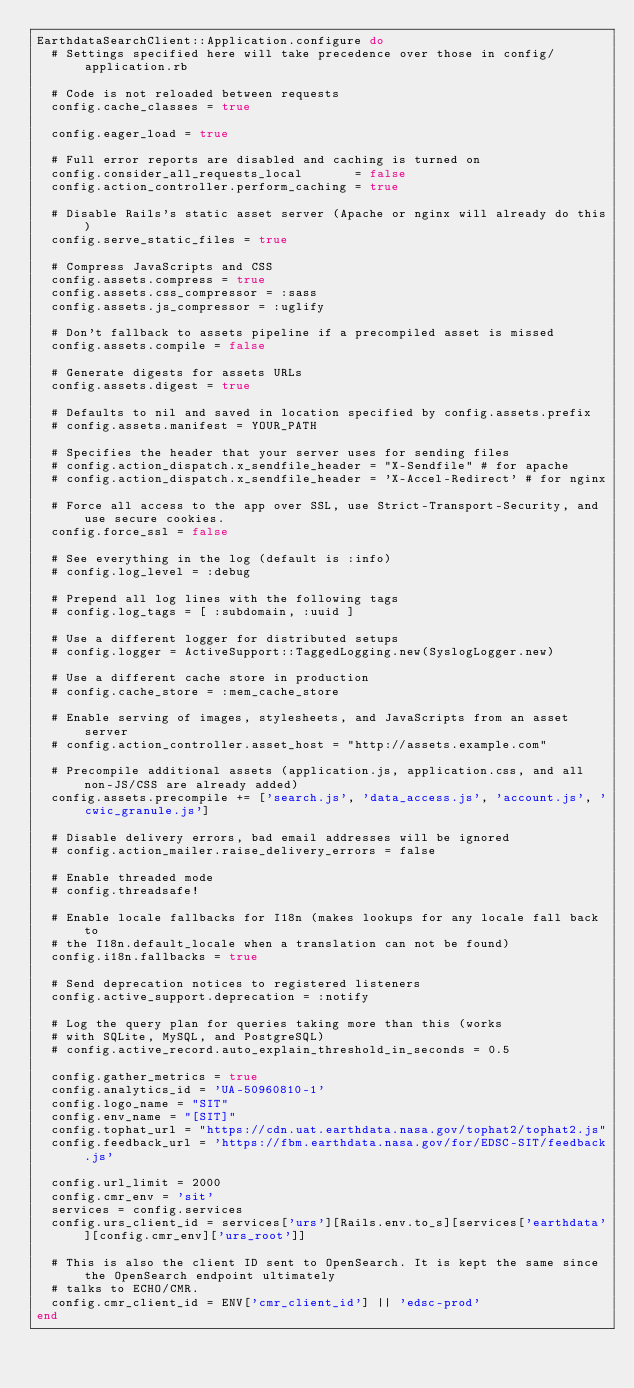Convert code to text. <code><loc_0><loc_0><loc_500><loc_500><_Ruby_>EarthdataSearchClient::Application.configure do
  # Settings specified here will take precedence over those in config/application.rb

  # Code is not reloaded between requests
  config.cache_classes = true

  config.eager_load = true

  # Full error reports are disabled and caching is turned on
  config.consider_all_requests_local       = false
  config.action_controller.perform_caching = true

  # Disable Rails's static asset server (Apache or nginx will already do this)
  config.serve_static_files = true

  # Compress JavaScripts and CSS
  config.assets.compress = true
  config.assets.css_compressor = :sass
  config.assets.js_compressor = :uglify

  # Don't fallback to assets pipeline if a precompiled asset is missed
  config.assets.compile = false

  # Generate digests for assets URLs
  config.assets.digest = true

  # Defaults to nil and saved in location specified by config.assets.prefix
  # config.assets.manifest = YOUR_PATH

  # Specifies the header that your server uses for sending files
  # config.action_dispatch.x_sendfile_header = "X-Sendfile" # for apache
  # config.action_dispatch.x_sendfile_header = 'X-Accel-Redirect' # for nginx

  # Force all access to the app over SSL, use Strict-Transport-Security, and use secure cookies.
  config.force_ssl = false

  # See everything in the log (default is :info)
  # config.log_level = :debug

  # Prepend all log lines with the following tags
  # config.log_tags = [ :subdomain, :uuid ]

  # Use a different logger for distributed setups
  # config.logger = ActiveSupport::TaggedLogging.new(SyslogLogger.new)

  # Use a different cache store in production
  # config.cache_store = :mem_cache_store

  # Enable serving of images, stylesheets, and JavaScripts from an asset server
  # config.action_controller.asset_host = "http://assets.example.com"

  # Precompile additional assets (application.js, application.css, and all non-JS/CSS are already added)
  config.assets.precompile += ['search.js', 'data_access.js', 'account.js', 'cwic_granule.js']

  # Disable delivery errors, bad email addresses will be ignored
  # config.action_mailer.raise_delivery_errors = false

  # Enable threaded mode
  # config.threadsafe!

  # Enable locale fallbacks for I18n (makes lookups for any locale fall back to
  # the I18n.default_locale when a translation can not be found)
  config.i18n.fallbacks = true

  # Send deprecation notices to registered listeners
  config.active_support.deprecation = :notify

  # Log the query plan for queries taking more than this (works
  # with SQLite, MySQL, and PostgreSQL)
  # config.active_record.auto_explain_threshold_in_seconds = 0.5

  config.gather_metrics = true
  config.analytics_id = 'UA-50960810-1'
  config.logo_name = "SIT"
  config.env_name = "[SIT]"
  config.tophat_url = "https://cdn.uat.earthdata.nasa.gov/tophat2/tophat2.js"
  config.feedback_url = 'https://fbm.earthdata.nasa.gov/for/EDSC-SIT/feedback.js'

  config.url_limit = 2000
  config.cmr_env = 'sit'
  services = config.services
  config.urs_client_id = services['urs'][Rails.env.to_s][services['earthdata'][config.cmr_env]['urs_root']]

  # This is also the client ID sent to OpenSearch. It is kept the same since the OpenSearch endpoint ultimately
  # talks to ECHO/CMR.
  config.cmr_client_id = ENV['cmr_client_id'] || 'edsc-prod'
end
</code> 